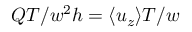<formula> <loc_0><loc_0><loc_500><loc_500>Q T / w ^ { 2 } h = \langle u _ { z } \rangle T / w</formula> 